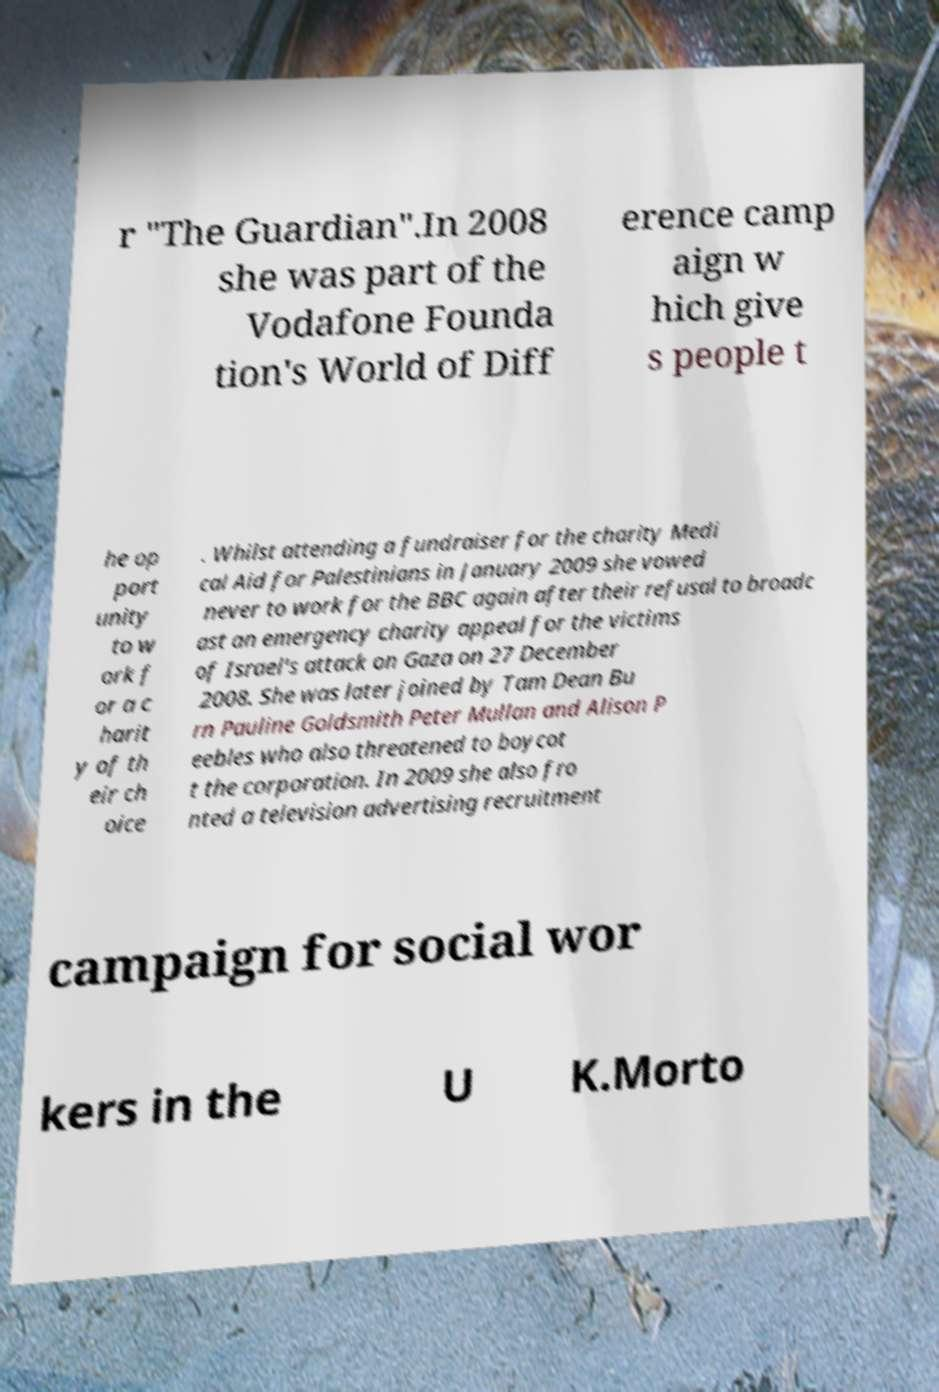Please read and relay the text visible in this image. What does it say? r "The Guardian".In 2008 she was part of the Vodafone Founda tion's World of Diff erence camp aign w hich give s people t he op port unity to w ork f or a c harit y of th eir ch oice . Whilst attending a fundraiser for the charity Medi cal Aid for Palestinians in January 2009 she vowed never to work for the BBC again after their refusal to broadc ast an emergency charity appeal for the victims of Israel's attack on Gaza on 27 December 2008. She was later joined by Tam Dean Bu rn Pauline Goldsmith Peter Mullan and Alison P eebles who also threatened to boycot t the corporation. In 2009 she also fro nted a television advertising recruitment campaign for social wor kers in the U K.Morto 